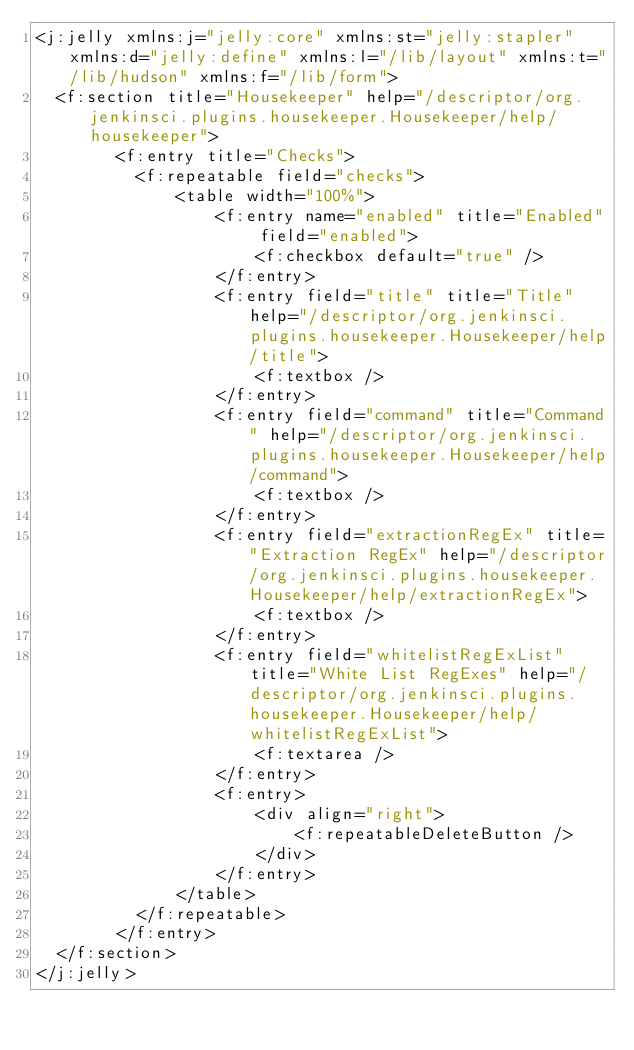<code> <loc_0><loc_0><loc_500><loc_500><_XML_><j:jelly xmlns:j="jelly:core" xmlns:st="jelly:stapler" xmlns:d="jelly:define" xmlns:l="/lib/layout" xmlns:t="/lib/hudson" xmlns:f="/lib/form">
  <f:section title="Housekeeper" help="/descriptor/org.jenkinsci.plugins.housekeeper.Housekeeper/help/housekeeper">
        <f:entry title="Checks">
          <f:repeatable field="checks">
              <table width="100%">
                  <f:entry name="enabled" title="Enabled" field="enabled">
                      <f:checkbox default="true" />
                  </f:entry>
                  <f:entry field="title" title="Title" help="/descriptor/org.jenkinsci.plugins.housekeeper.Housekeeper/help/title">
                      <f:textbox />
                  </f:entry>
                  <f:entry field="command" title="Command" help="/descriptor/org.jenkinsci.plugins.housekeeper.Housekeeper/help/command">
                      <f:textbox />
                  </f:entry>
                  <f:entry field="extractionRegEx" title="Extraction RegEx" help="/descriptor/org.jenkinsci.plugins.housekeeper.Housekeeper/help/extractionRegEx">
                      <f:textbox />
                  </f:entry>
                  <f:entry field="whitelistRegExList" title="White List RegExes" help="/descriptor/org.jenkinsci.plugins.housekeeper.Housekeeper/help/whitelistRegExList">
                      <f:textarea />
                  </f:entry>
                  <f:entry>
                      <div align="right">
                          <f:repeatableDeleteButton />
                      </div>
                  </f:entry>
              </table>
          </f:repeatable>
        </f:entry>
  </f:section>
</j:jelly></code> 